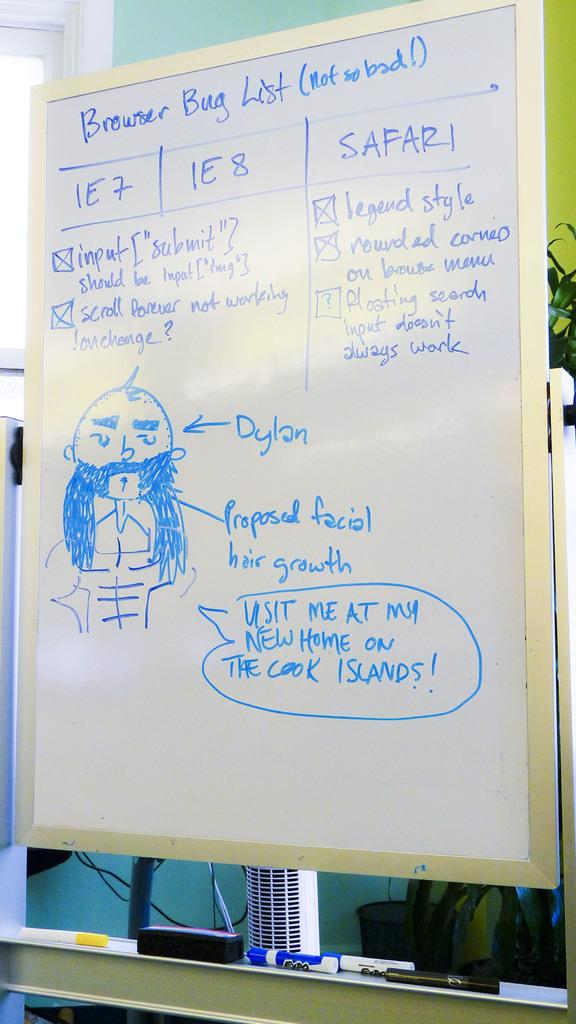<image>
Write a terse but informative summary of the picture. the name Dylan is on the white board 